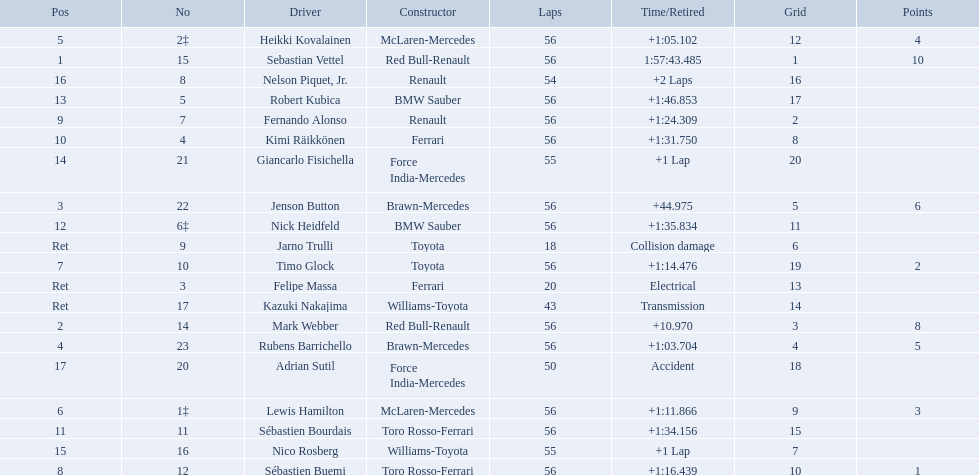Who are all of the drivers? Sebastian Vettel, Mark Webber, Jenson Button, Rubens Barrichello, Heikki Kovalainen, Lewis Hamilton, Timo Glock, Sébastien Buemi, Fernando Alonso, Kimi Räikkönen, Sébastien Bourdais, Nick Heidfeld, Robert Kubica, Giancarlo Fisichella, Nico Rosberg, Nelson Piquet, Jr., Adrian Sutil, Kazuki Nakajima, Felipe Massa, Jarno Trulli. Who were their constructors? Red Bull-Renault, Red Bull-Renault, Brawn-Mercedes, Brawn-Mercedes, McLaren-Mercedes, McLaren-Mercedes, Toyota, Toro Rosso-Ferrari, Renault, Ferrari, Toro Rosso-Ferrari, BMW Sauber, BMW Sauber, Force India-Mercedes, Williams-Toyota, Renault, Force India-Mercedes, Williams-Toyota, Ferrari, Toyota. Who was the first listed driver to not drive a ferrari?? Sebastian Vettel. 